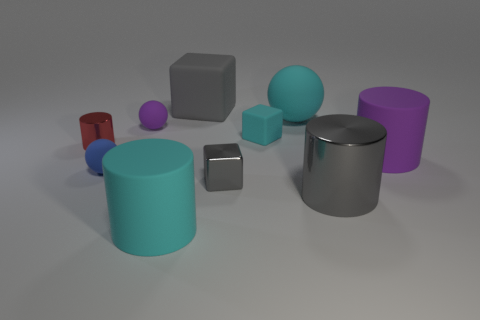How many gray things are either tiny metal cylinders or blocks?
Make the answer very short. 2. Are there any big rubber things that have the same color as the large rubber ball?
Keep it short and to the point. Yes. There is a gray cube that is the same material as the small cyan thing; what size is it?
Your answer should be compact. Large. How many spheres are large green things or big cyan objects?
Offer a very short reply. 1. Is the number of tiny purple things greater than the number of small things?
Make the answer very short. No. How many purple balls are the same size as the red cylinder?
Your response must be concise. 1. There is a large matte object that is the same color as the big matte ball; what shape is it?
Provide a succinct answer. Cylinder. What number of things are either small matte objects that are to the left of the big rubber block or small green metal spheres?
Your answer should be very brief. 2. Are there fewer small red metal cylinders than large purple metallic spheres?
Offer a very short reply. No. The small blue thing that is the same material as the purple sphere is what shape?
Ensure brevity in your answer.  Sphere. 